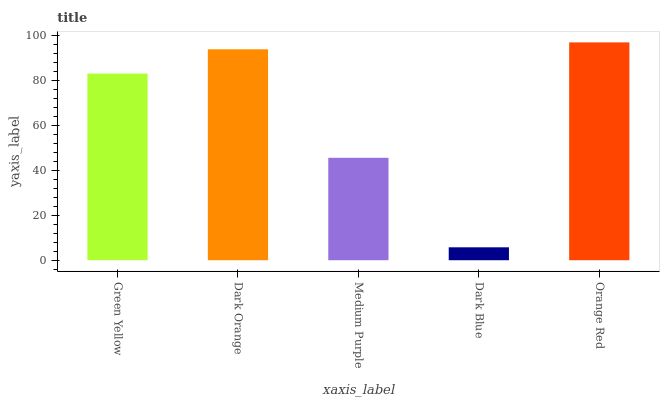Is Dark Blue the minimum?
Answer yes or no. Yes. Is Orange Red the maximum?
Answer yes or no. Yes. Is Dark Orange the minimum?
Answer yes or no. No. Is Dark Orange the maximum?
Answer yes or no. No. Is Dark Orange greater than Green Yellow?
Answer yes or no. Yes. Is Green Yellow less than Dark Orange?
Answer yes or no. Yes. Is Green Yellow greater than Dark Orange?
Answer yes or no. No. Is Dark Orange less than Green Yellow?
Answer yes or no. No. Is Green Yellow the high median?
Answer yes or no. Yes. Is Green Yellow the low median?
Answer yes or no. Yes. Is Dark Orange the high median?
Answer yes or no. No. Is Medium Purple the low median?
Answer yes or no. No. 